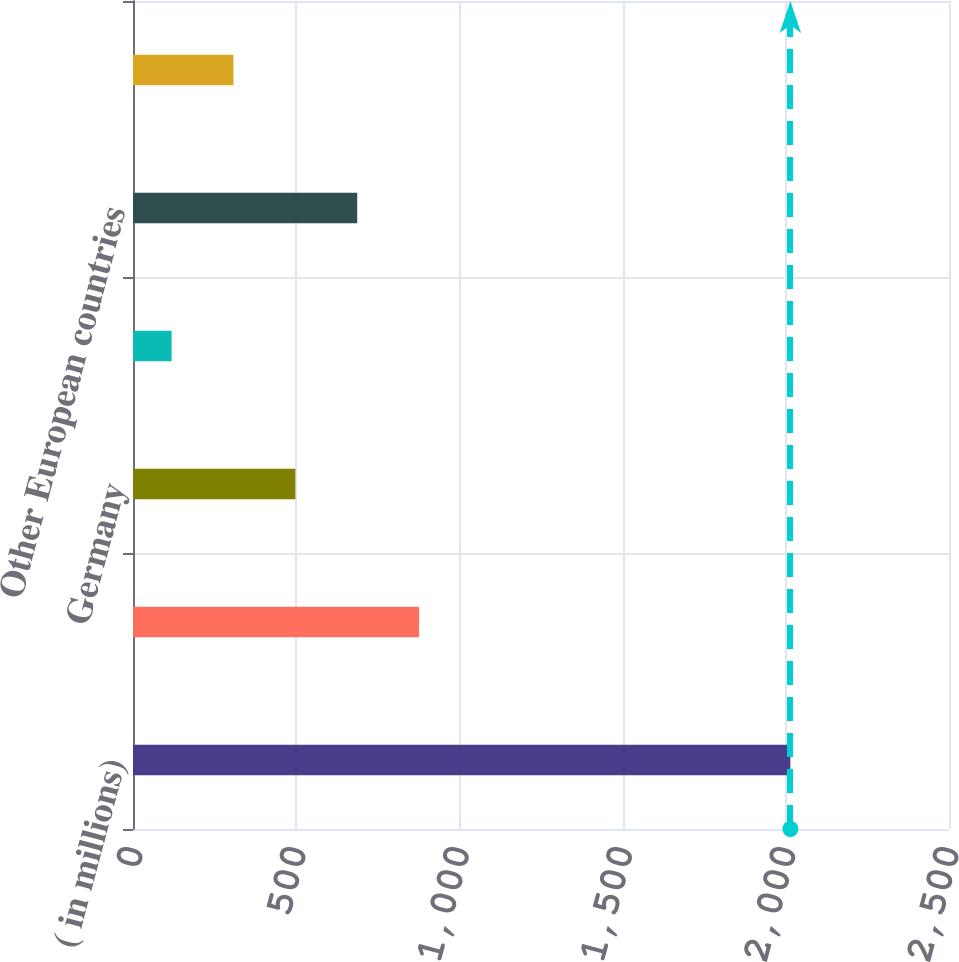Convert chart. <chart><loc_0><loc_0><loc_500><loc_500><bar_chart><fcel>( in millions)<fcel>United States<fcel>Germany<fcel>France<fcel>Other European countries<fcel>Other<nl><fcel>2014<fcel>876.52<fcel>497.36<fcel>118.2<fcel>686.94<fcel>307.78<nl></chart> 